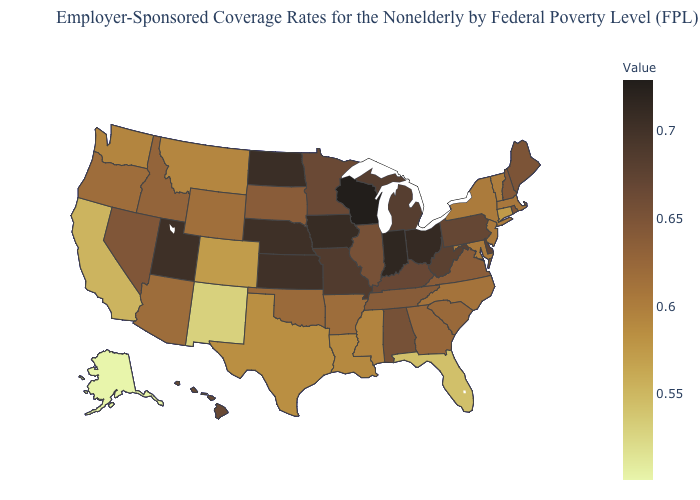Does Montana have a higher value than Ohio?
Quick response, please. No. Does Oregon have a lower value than Delaware?
Concise answer only. Yes. Which states have the lowest value in the South?
Give a very brief answer. Florida. Which states have the lowest value in the USA?
Keep it brief. Alaska. Does Alaska have the lowest value in the West?
Concise answer only. Yes. 